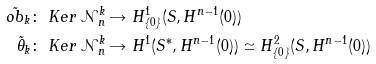<formula> <loc_0><loc_0><loc_500><loc_500>\tilde { o b } _ { k } \colon & \ K e r \, \mathcal { N } _ { n } ^ { k } \rightarrow H ^ { 1 } _ { \{ 0 \} } ( S , H ^ { n - 1 } ( 0 ) ) \\ \tilde { \theta } _ { k } \colon & \ K e r \, \mathcal { N } _ { n } ^ { k } \rightarrow H ^ { 1 } ( S ^ { * } , H ^ { n - 1 } ( 0 ) ) \simeq H ^ { 2 } _ { \{ 0 \} } ( S , H ^ { n - 1 } ( 0 ) )</formula> 